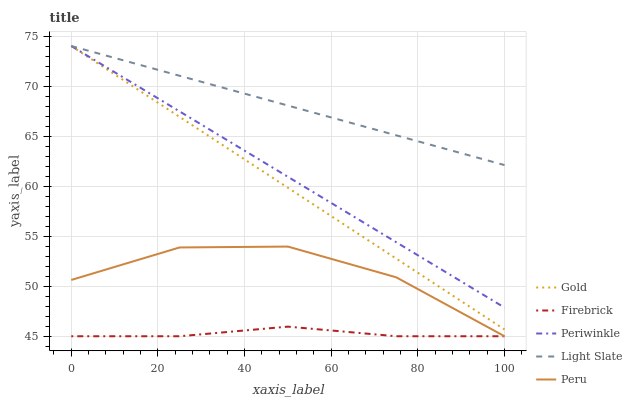Does Firebrick have the minimum area under the curve?
Answer yes or no. Yes. Does Light Slate have the maximum area under the curve?
Answer yes or no. Yes. Does Periwinkle have the minimum area under the curve?
Answer yes or no. No. Does Periwinkle have the maximum area under the curve?
Answer yes or no. No. Is Periwinkle the smoothest?
Answer yes or no. Yes. Is Peru the roughest?
Answer yes or no. Yes. Is Firebrick the smoothest?
Answer yes or no. No. Is Firebrick the roughest?
Answer yes or no. No. Does Firebrick have the lowest value?
Answer yes or no. Yes. Does Periwinkle have the lowest value?
Answer yes or no. No. Does Gold have the highest value?
Answer yes or no. Yes. Does Firebrick have the highest value?
Answer yes or no. No. Is Firebrick less than Periwinkle?
Answer yes or no. Yes. Is Light Slate greater than Peru?
Answer yes or no. Yes. Does Periwinkle intersect Gold?
Answer yes or no. Yes. Is Periwinkle less than Gold?
Answer yes or no. No. Is Periwinkle greater than Gold?
Answer yes or no. No. Does Firebrick intersect Periwinkle?
Answer yes or no. No. 